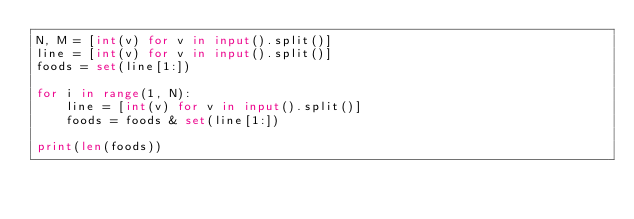Convert code to text. <code><loc_0><loc_0><loc_500><loc_500><_Python_>N, M = [int(v) for v in input().split()]
line = [int(v) for v in input().split()]
foods = set(line[1:])

for i in range(1, N):
    line = [int(v) for v in input().split()]
    foods = foods & set(line[1:])

print(len(foods))
</code> 